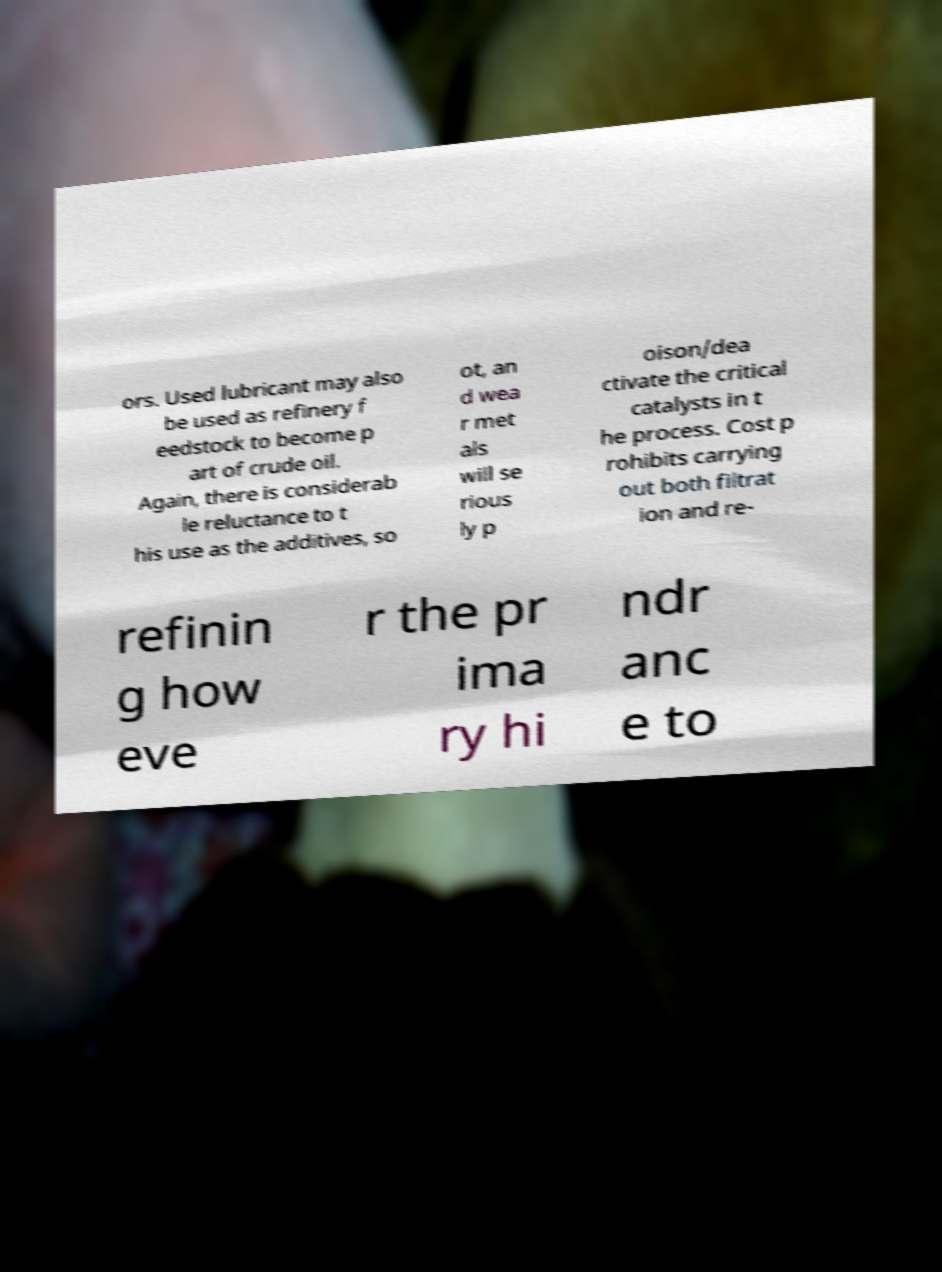Please identify and transcribe the text found in this image. ors. Used lubricant may also be used as refinery f eedstock to become p art of crude oil. Again, there is considerab le reluctance to t his use as the additives, so ot, an d wea r met als will se rious ly p oison/dea ctivate the critical catalysts in t he process. Cost p rohibits carrying out both filtrat ion and re- refinin g how eve r the pr ima ry hi ndr anc e to 